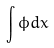<formula> <loc_0><loc_0><loc_500><loc_500>\int \phi d x</formula> 